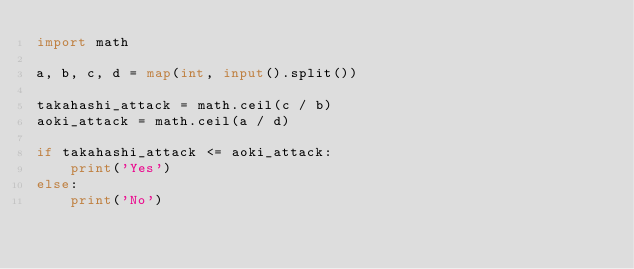<code> <loc_0><loc_0><loc_500><loc_500><_Python_>import math

a, b, c, d = map(int, input().split())

takahashi_attack = math.ceil(c / b)
aoki_attack = math.ceil(a / d)

if takahashi_attack <= aoki_attack:
    print('Yes')
else:
    print('No')
</code> 